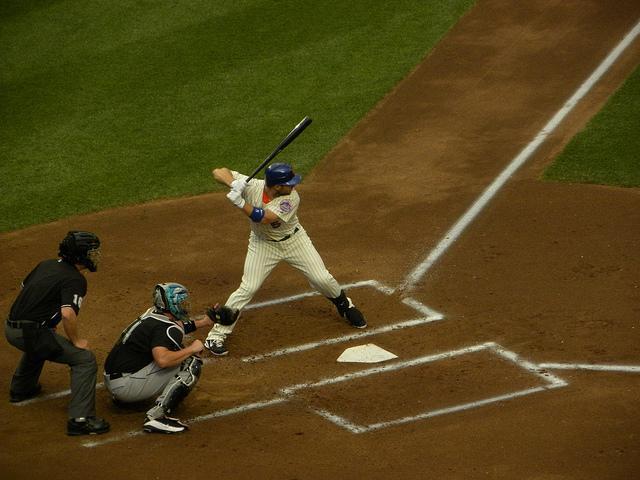How many people are there?
Give a very brief answer. 3. 